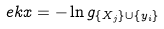Convert formula to latex. <formula><loc_0><loc_0><loc_500><loc_500>\ e k x = - \ln g _ { \{ X _ { j } \} \cup \{ y _ { i } \} }</formula> 